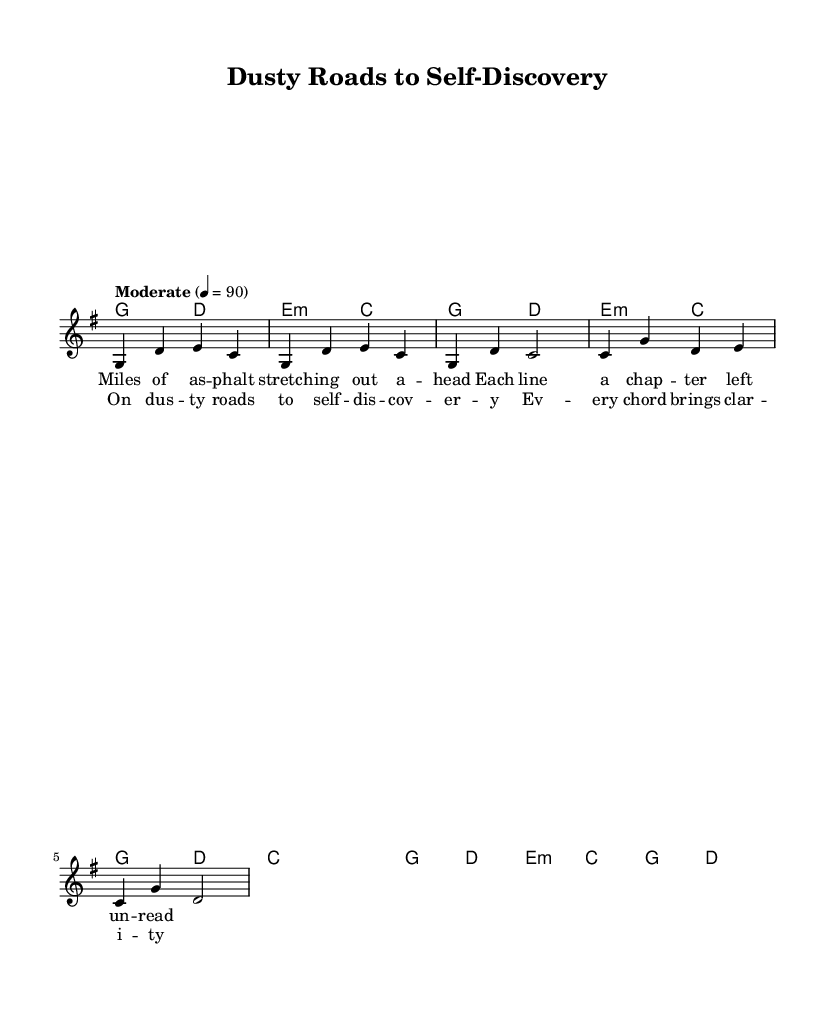What is the key signature of this music? The key signature means looking at the start of the staff for sharp or flat symbols. In this case, there is one sharp, indicating the key is G major.
Answer: G major What is the time signature of this piece? The time signature is indicated at the beginning of the piece and is expressed as a fraction. Here, it is four beats per measure with a quarter note receiving one beat, shown as 4/4.
Answer: 4/4 What is the tempo marking? The tempo marking indicates the speed of the music and is found at the beginning of the score. It states "Moderate" with a metronome marking of 90 beats per minute.
Answer: Moderate How many measures are in the verse? To determine the number of measures in the verse, we can count the distinct measures in the melody section labeled as the verse. The verse contains four measures.
Answer: Four What musical form is this piece? The form can be identified by looking at how the sections are arranged. In this piece, the structure follows a verse-chorus format, implying verses are followed by choruses.
Answer: Verse-Chorus What are the lyric themes in the chorus? To derive the theme from the lyrics, analyze the textual content of the chorus. It discusses self-discovery and gaining clarity through musical expression.
Answer: Self-discovery How does the melody relate to the theme of personal growth? The melody captures the essence of introspection through its rise and fall, mirroring the emotional journey represented in the lyrics about personal struggles and realization.
Answer: Emotional journey 